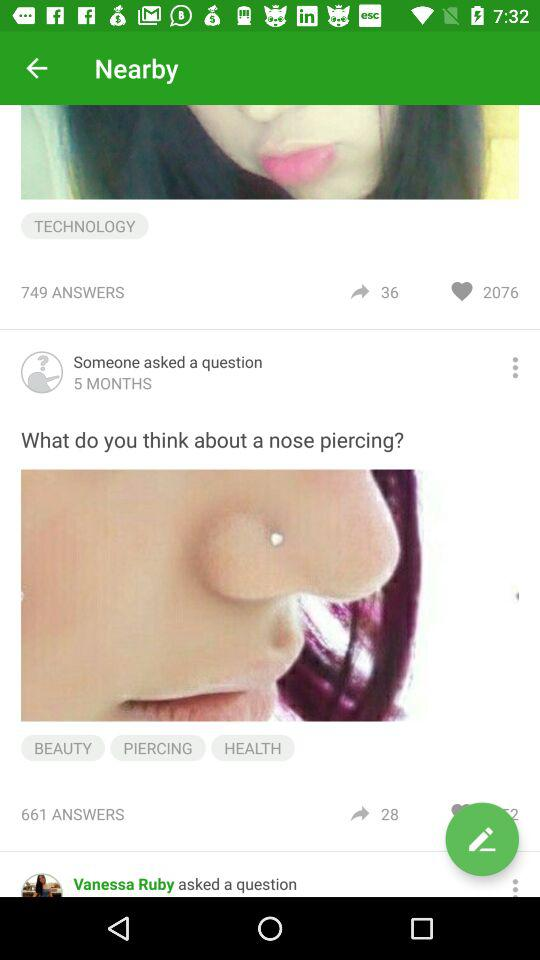How many likes does "What do you think about a nose piercing?" have?
When the provided information is insufficient, respond with <no answer>. <no answer> 